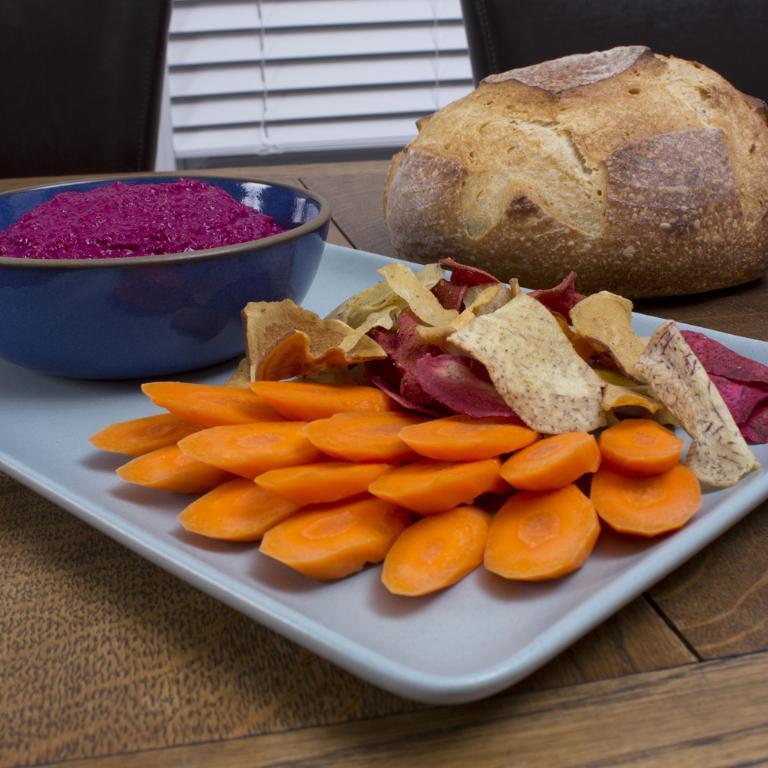Describe this image in one or two sentences. In the foreground of this image, there are few cut vegetables on a platter and also a paste in a bowl on a platter which is kept on a wooden surface. On the right, there is a bun. In the background, it seems like a window blind and two chairs. 